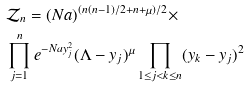<formula> <loc_0><loc_0><loc_500><loc_500>& \mathcal { Z } _ { n } = ( N a ) ^ { ( n ( n - 1 ) / 2 + n + \mu ) / 2 } \times \\ & \prod _ { j = 1 } ^ { n } e ^ { - N a y _ { j } ^ { 2 } } ( \Lambda - y _ { j } ) ^ { \mu } \prod _ { 1 \leq j < k \leq n } ( y _ { k } - y _ { j } ) ^ { 2 }</formula> 